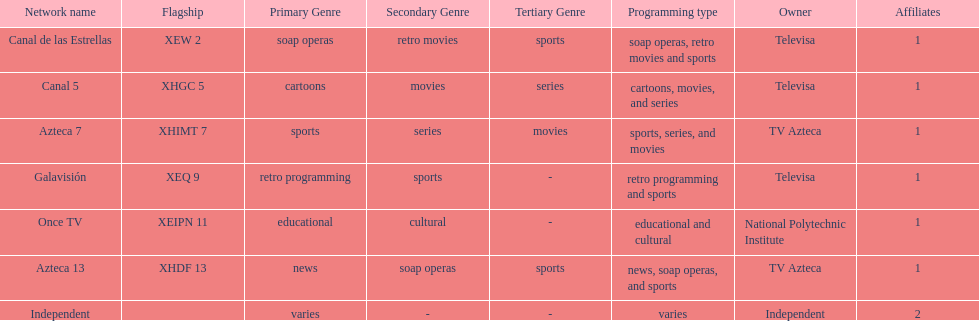What is the only network owned by national polytechnic institute? Once TV. 